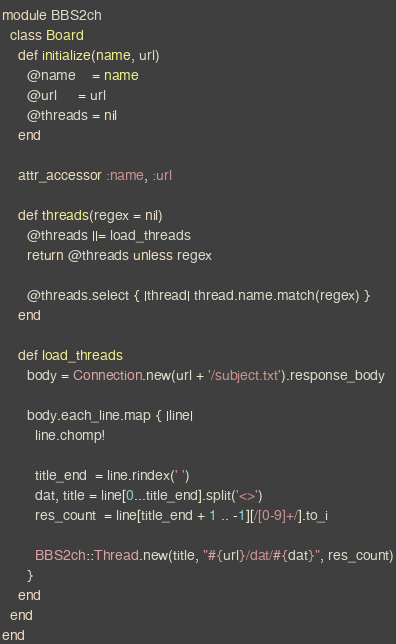Convert code to text. <code><loc_0><loc_0><loc_500><loc_500><_Ruby_>module BBS2ch
  class Board
    def initialize(name, url)
      @name    = name
      @url     = url
      @threads = nil
    end

    attr_accessor :name, :url

    def threads(regex = nil)
      @threads ||= load_threads
      return @threads unless regex

      @threads.select { |thread| thread.name.match(regex) }
    end

    def load_threads
      body = Connection.new(url + '/subject.txt').response_body

      body.each_line.map { |line|
        line.chomp!

        title_end  = line.rindex(' ')
        dat, title = line[0...title_end].split('<>')
        res_count  = line[title_end + 1 .. -1][/[0-9]+/].to_i

        BBS2ch::Thread.new(title, "#{url}/dat/#{dat}", res_count)
      }
    end
  end
end
</code> 